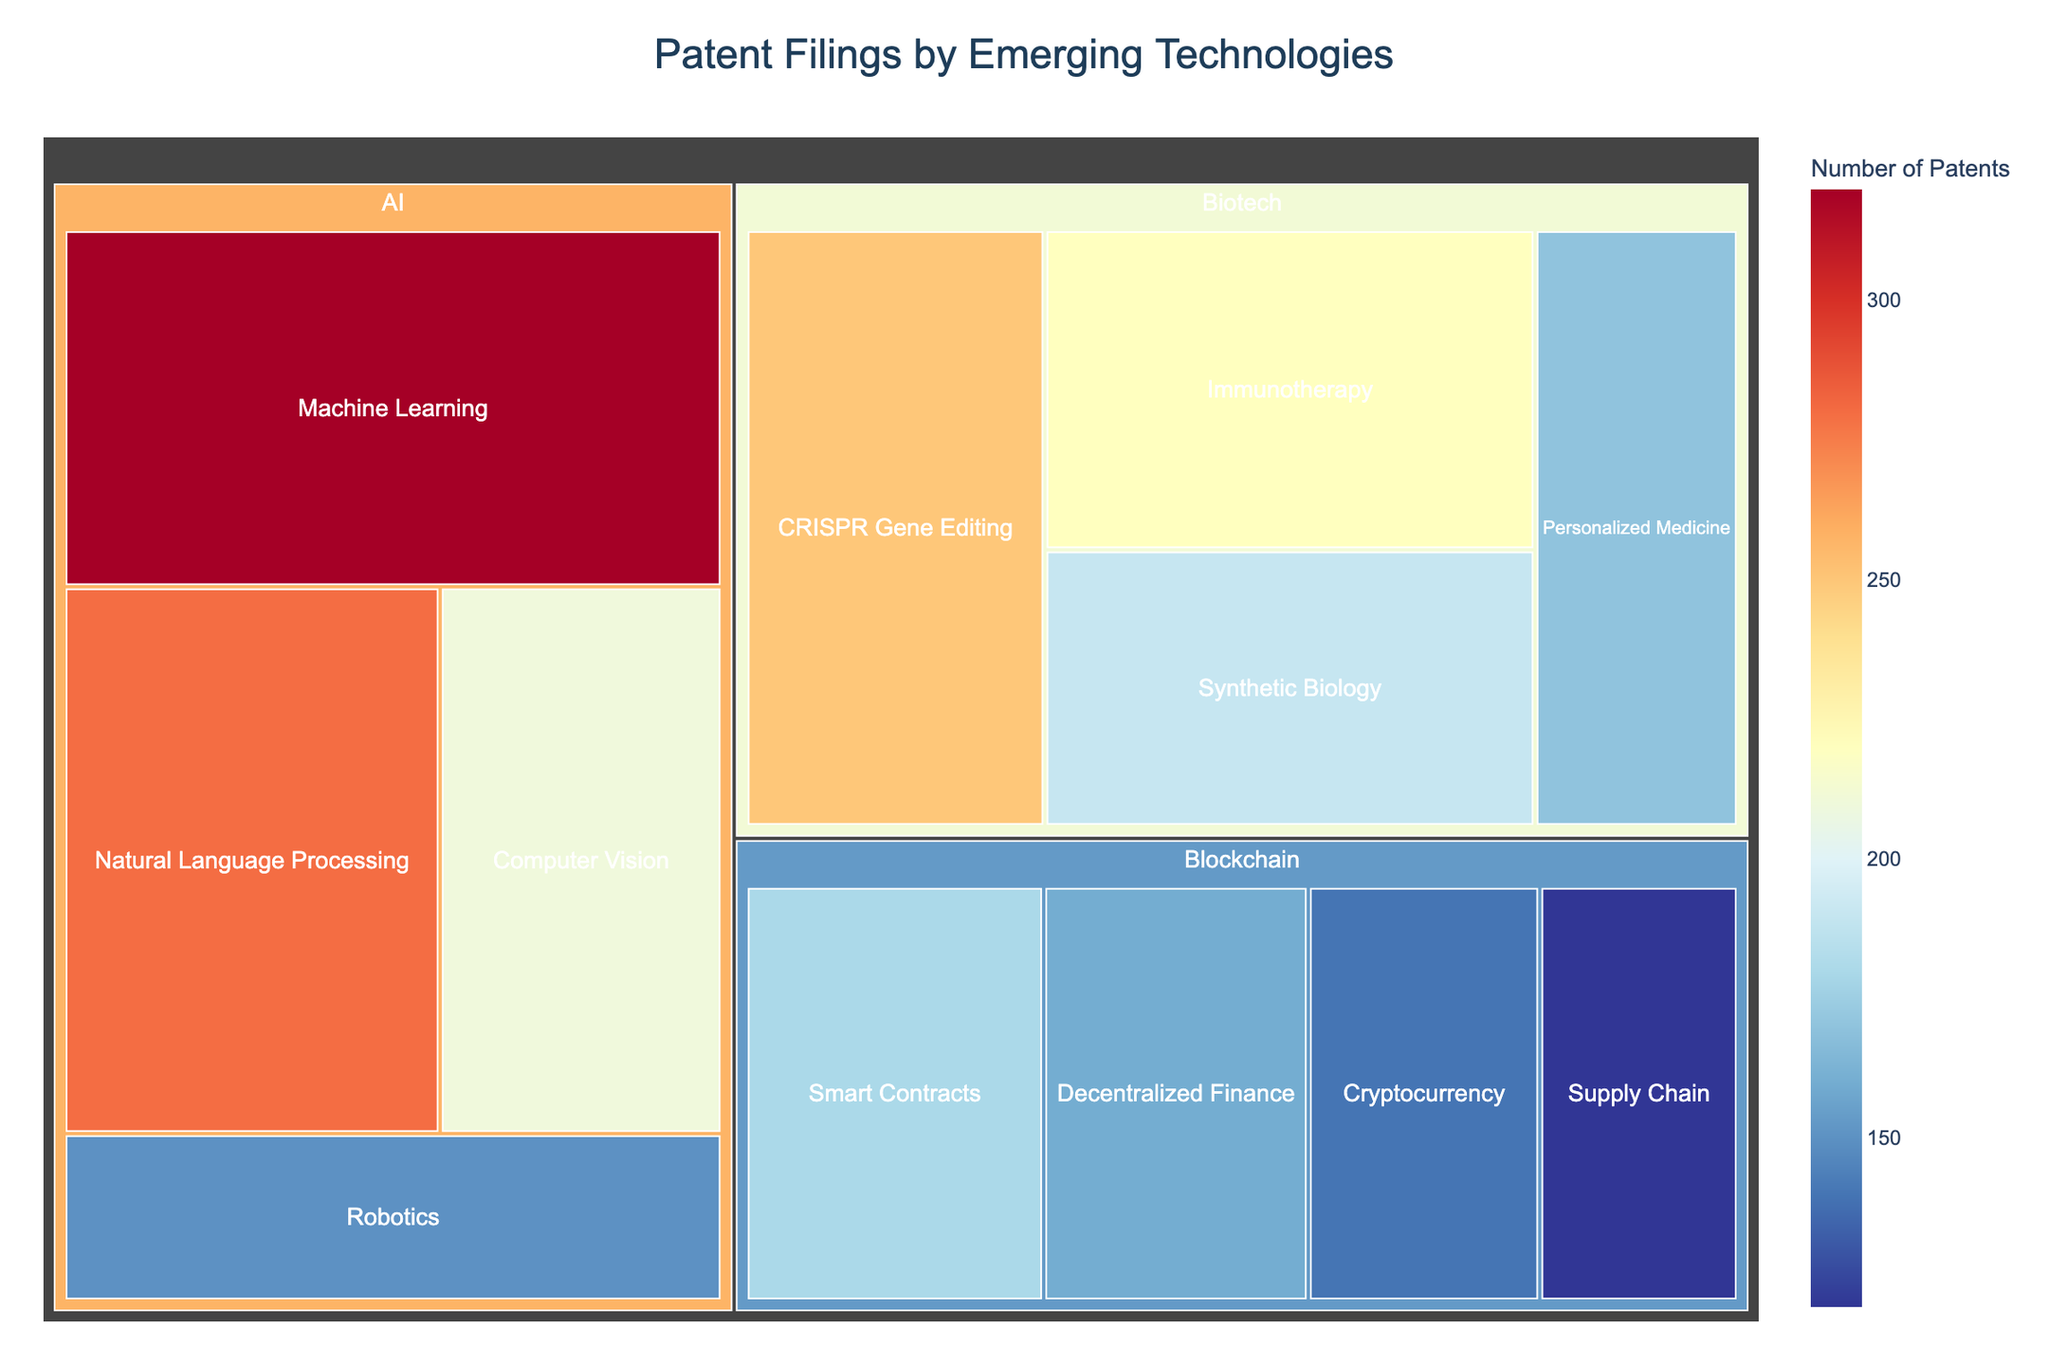What's the title of the treemap? The title of the treemap is usually displayed prominently at the top of the chart.
Answer: Patent Filings by Emerging Technologies How many subcategories are there within Artificial Intelligence (AI)? The treemap visually represents each subcategory within the main category using blocks. Simply count the subcategories under the AI section.
Answer: Four Which subcategory has the highest number of patents in the AI category? In the AI section of the treemap, compare the sizes and/or check the values of each subcategory. The largest block or the highest value indicates the most patents.
Answer: Machine Learning Compare the number of patents in Smart Contracts and CRISPR Gene Editing. Which has more patents and by how many? Locate the Smart Contracts subcategory under Blockchain and the CRISPR Gene Editing subcategory under Biotech. Subtract the smaller number from the larger one.
Answer: CRISPR Gene Editing, by 70 patents What's the total number of biotech patents represented in the treemap? Sum the values of all subcategories under the Biotech category. Add up CRISPR Gene Editing, Immunotherapy, Synthetic Biology, and Personalized Medicine.
Answer: 830 Which category has the fewest number of patents overall? Sum the number of patents for each of the main categories (AI, Blockchain, and Biotech). The category with the smallest total has the fewest patents.
Answer: Blockchain What's the smallest subcategory in terms of patent filings, and how many patents does it represent? Identify the subcategory with the smallest block size or lowest value across all categories.
Answer: Blockchain, Supply Chain with 120 patents Compare the total number of AI and Blockchain patents. Which has more, and by what margin? Sum all subcategory values within AI and Blockchain. Subtract the total Blockchain patents from the total AI patents.
Answer: AI has more by 670 patents Which subcategory within Biotech has the second highest number of patents? Order the subcategories by their value under the Biotech section and identify the second highest.
Answer: Immunotherapy If a new subcategory named "AI Ethics" with 100 patents is added to the AI category, what would be the new total for AI patents? Add the new subcategory value to the existing total of AI patents. Sum up all AI subcategories and add 100.
Answer: 1060 